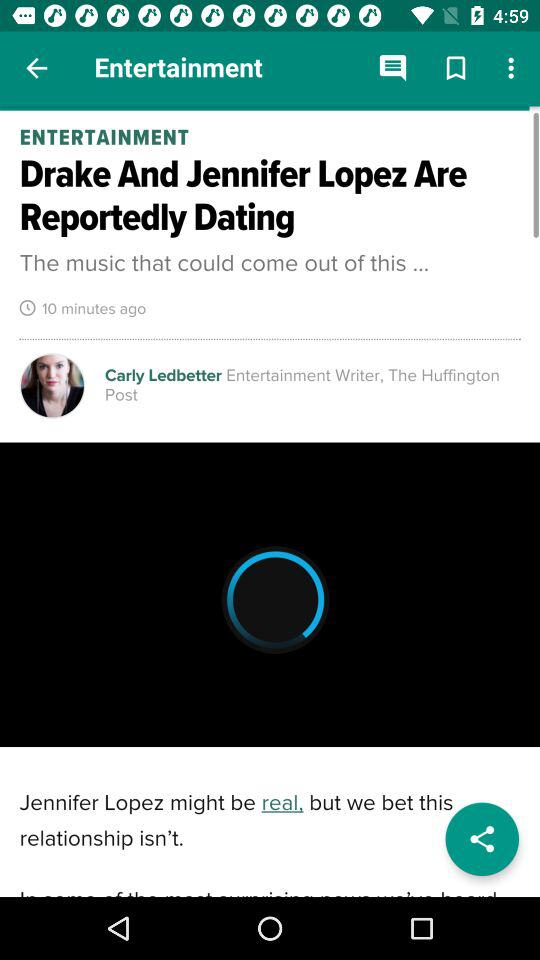What's the writer's name? The writer's name is Carly Ledbetter. 